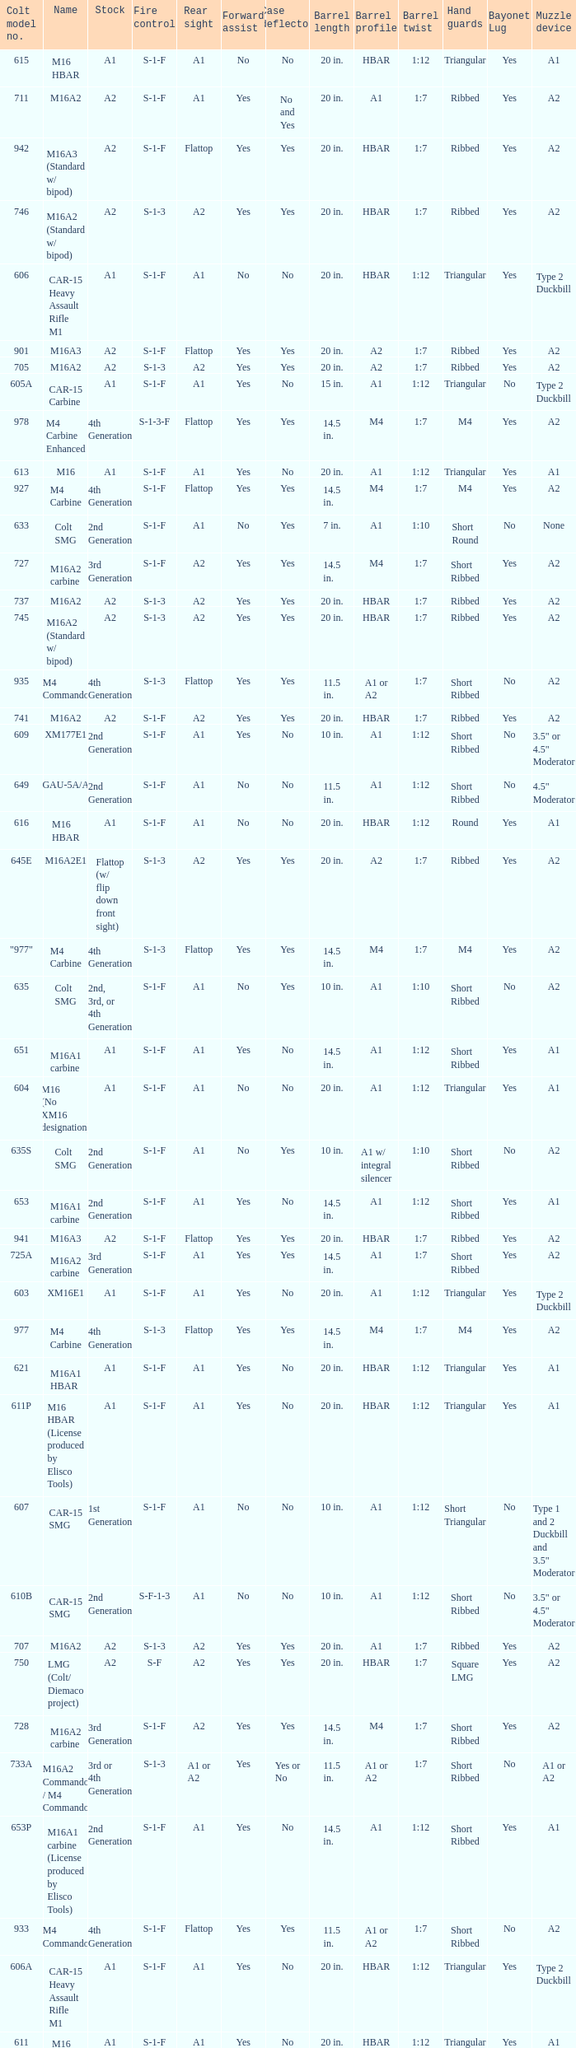What are the Colt model numbers of the models named GAU-5A/A, with no bayonet lug, no case deflector and stock of 2nd generation?  630, 649. 